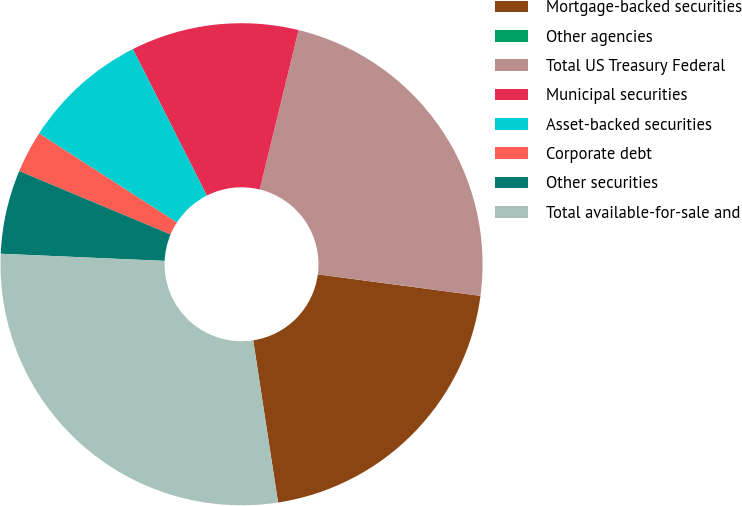<chart> <loc_0><loc_0><loc_500><loc_500><pie_chart><fcel>Mortgage-backed securities<fcel>Other agencies<fcel>Total US Treasury Federal<fcel>Municipal securities<fcel>Asset-backed securities<fcel>Corporate debt<fcel>Other securities<fcel>Total available-for-sale and<nl><fcel>20.48%<fcel>0.0%<fcel>23.29%<fcel>11.24%<fcel>8.43%<fcel>2.81%<fcel>5.62%<fcel>28.11%<nl></chart> 